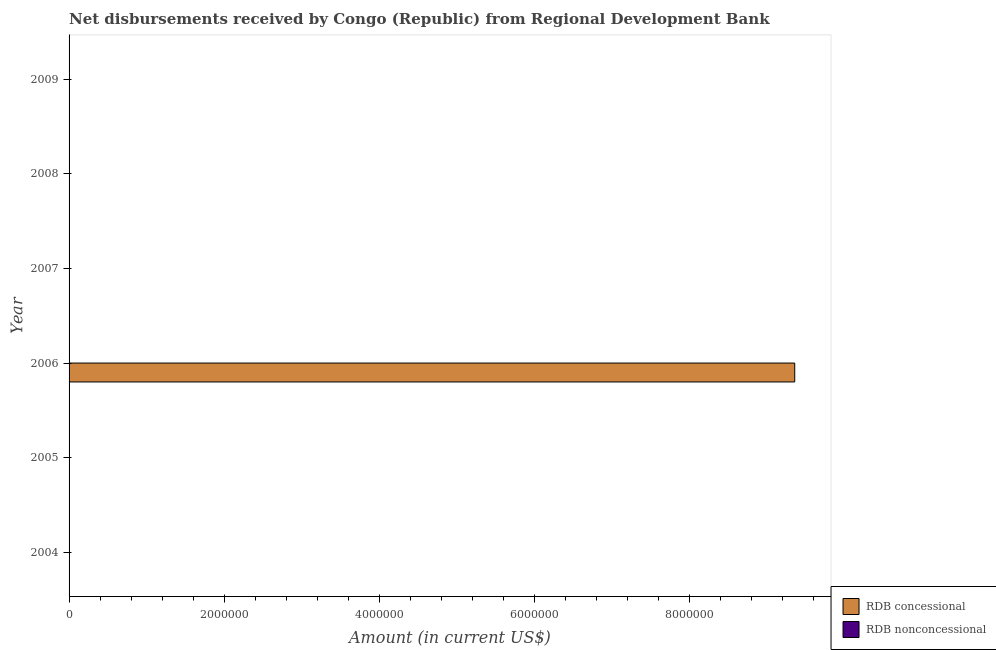How many different coloured bars are there?
Your answer should be very brief. 1. Are the number of bars per tick equal to the number of legend labels?
Offer a very short reply. No. How many bars are there on the 4th tick from the top?
Ensure brevity in your answer.  1. How many bars are there on the 5th tick from the bottom?
Ensure brevity in your answer.  0. In how many cases, is the number of bars for a given year not equal to the number of legend labels?
Your response must be concise. 6. Across all years, what is the maximum net concessional disbursements from rdb?
Keep it short and to the point. 9.36e+06. In which year was the net concessional disbursements from rdb maximum?
Provide a short and direct response. 2006. What is the difference between the net concessional disbursements from rdb in 2009 and the net non concessional disbursements from rdb in 2004?
Keep it short and to the point. 0. What is the average net concessional disbursements from rdb per year?
Ensure brevity in your answer.  1.56e+06. What is the difference between the highest and the lowest net concessional disbursements from rdb?
Keep it short and to the point. 9.36e+06. Are all the bars in the graph horizontal?
Your answer should be very brief. Yes. Are the values on the major ticks of X-axis written in scientific E-notation?
Give a very brief answer. No. How many legend labels are there?
Offer a very short reply. 2. What is the title of the graph?
Make the answer very short. Net disbursements received by Congo (Republic) from Regional Development Bank. Does "Depositors" appear as one of the legend labels in the graph?
Your answer should be very brief. No. What is the Amount (in current US$) in RDB nonconcessional in 2004?
Your answer should be very brief. 0. What is the Amount (in current US$) of RDB concessional in 2005?
Your answer should be compact. 0. What is the Amount (in current US$) of RDB concessional in 2006?
Ensure brevity in your answer.  9.36e+06. What is the Amount (in current US$) in RDB nonconcessional in 2006?
Offer a terse response. 0. Across all years, what is the maximum Amount (in current US$) in RDB concessional?
Make the answer very short. 9.36e+06. Across all years, what is the minimum Amount (in current US$) in RDB concessional?
Ensure brevity in your answer.  0. What is the total Amount (in current US$) of RDB concessional in the graph?
Your answer should be compact. 9.36e+06. What is the average Amount (in current US$) of RDB concessional per year?
Provide a short and direct response. 1.56e+06. What is the average Amount (in current US$) in RDB nonconcessional per year?
Provide a succinct answer. 0. What is the difference between the highest and the lowest Amount (in current US$) of RDB concessional?
Ensure brevity in your answer.  9.36e+06. 